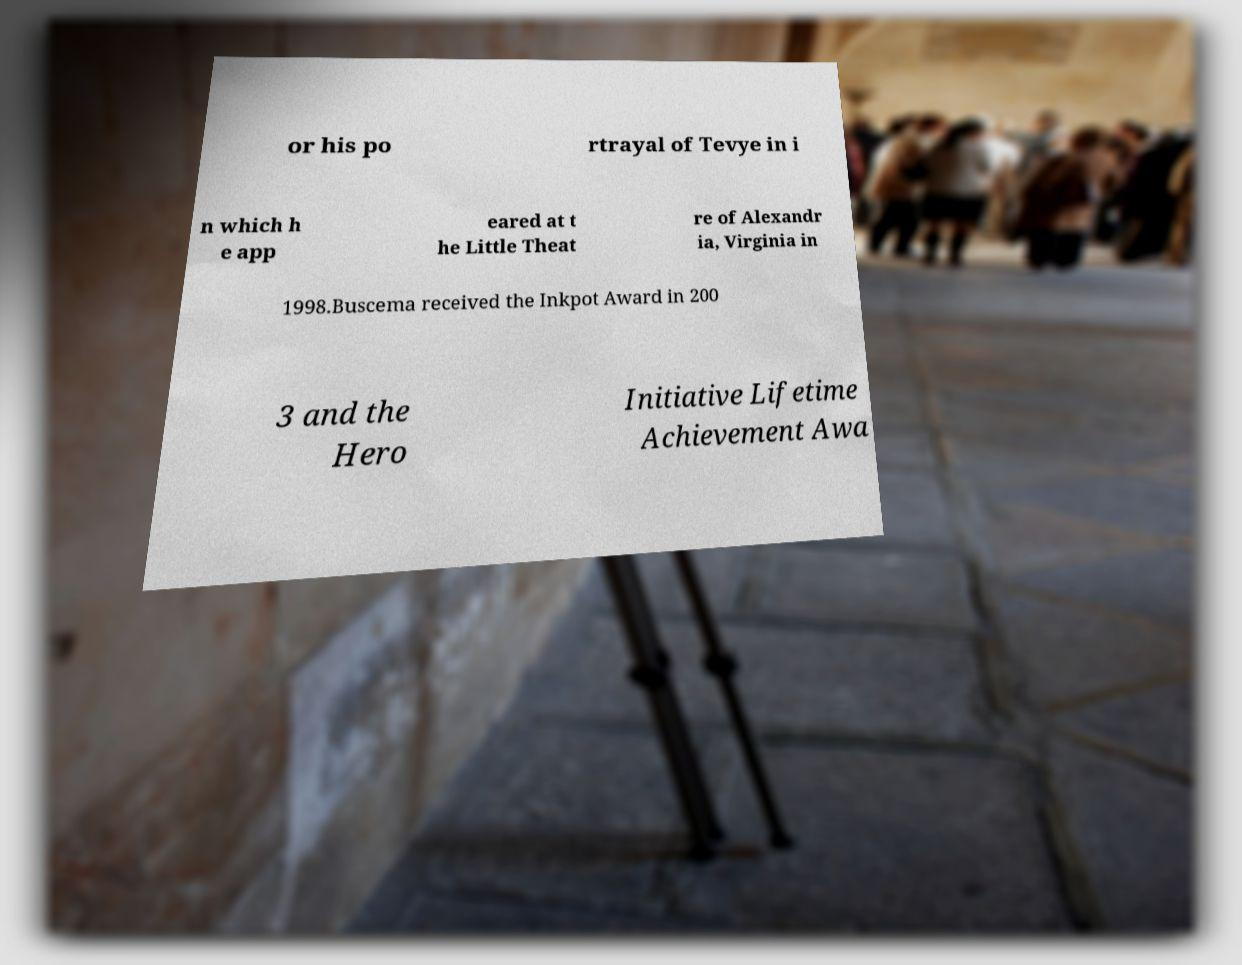Please identify and transcribe the text found in this image. or his po rtrayal of Tevye in i n which h e app eared at t he Little Theat re of Alexandr ia, Virginia in 1998.Buscema received the Inkpot Award in 200 3 and the Hero Initiative Lifetime Achievement Awa 